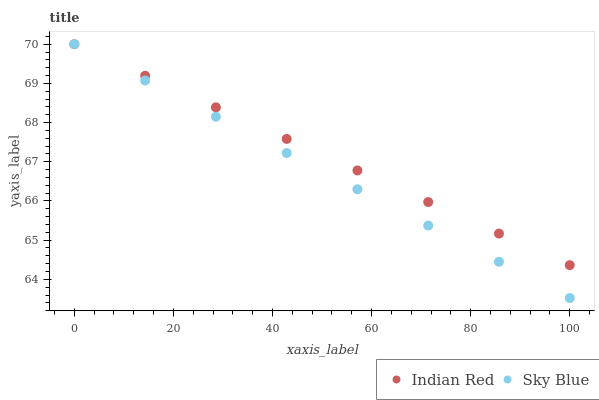Does Sky Blue have the minimum area under the curve?
Answer yes or no. Yes. Does Indian Red have the maximum area under the curve?
Answer yes or no. Yes. Does Indian Red have the minimum area under the curve?
Answer yes or no. No. Is Sky Blue the smoothest?
Answer yes or no. Yes. Is Indian Red the roughest?
Answer yes or no. Yes. Is Indian Red the smoothest?
Answer yes or no. No. Does Sky Blue have the lowest value?
Answer yes or no. Yes. Does Indian Red have the lowest value?
Answer yes or no. No. Does Indian Red have the highest value?
Answer yes or no. Yes. Does Indian Red intersect Sky Blue?
Answer yes or no. Yes. Is Indian Red less than Sky Blue?
Answer yes or no. No. Is Indian Red greater than Sky Blue?
Answer yes or no. No. 